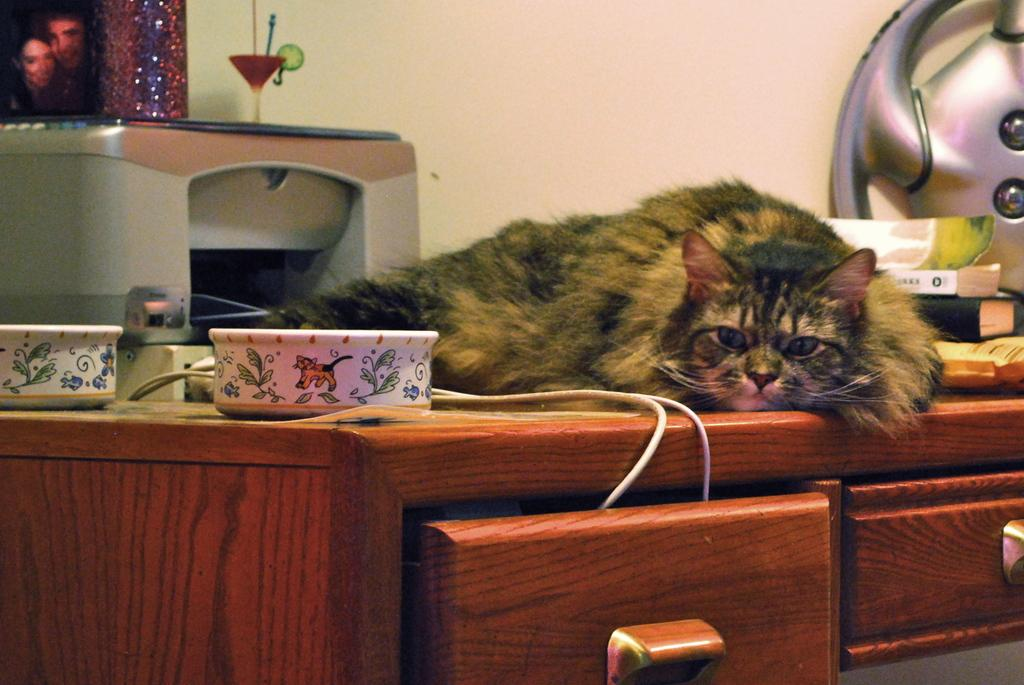What animal is lying on the table in the image? There is a cat lying on a table in the image. How many bowls are on the table? There are two bowls on the table. What is a characteristic of the bowls? The bowls are printed. What else can be found on the table besides the cat and bowls? There are books and other articles on the table. What type of storage is available under the table? There are two drawers under the table. Can you see any mist forming around the cat in the image? There is no mist present in the image; it is a clear scene with a cat lying on a table. 